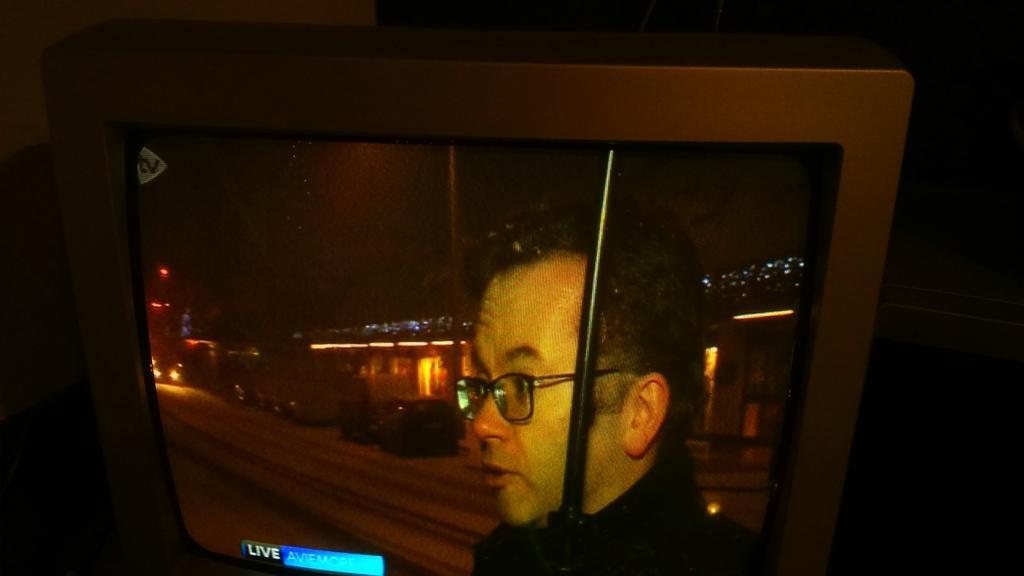Please provide a concise description of this image. In this picture there is a computer screen, Inside we can see the man standing in the front and looking on the left side. Behind there is a view of the city with lights. 